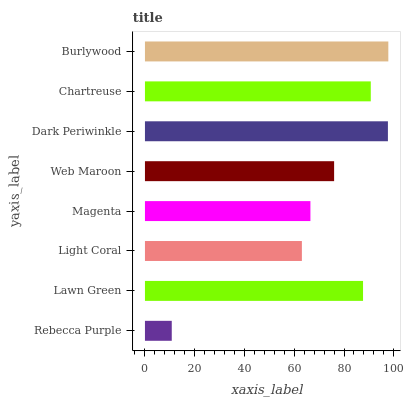Is Rebecca Purple the minimum?
Answer yes or no. Yes. Is Burlywood the maximum?
Answer yes or no. Yes. Is Lawn Green the minimum?
Answer yes or no. No. Is Lawn Green the maximum?
Answer yes or no. No. Is Lawn Green greater than Rebecca Purple?
Answer yes or no. Yes. Is Rebecca Purple less than Lawn Green?
Answer yes or no. Yes. Is Rebecca Purple greater than Lawn Green?
Answer yes or no. No. Is Lawn Green less than Rebecca Purple?
Answer yes or no. No. Is Lawn Green the high median?
Answer yes or no. Yes. Is Web Maroon the low median?
Answer yes or no. Yes. Is Dark Periwinkle the high median?
Answer yes or no. No. Is Chartreuse the low median?
Answer yes or no. No. 